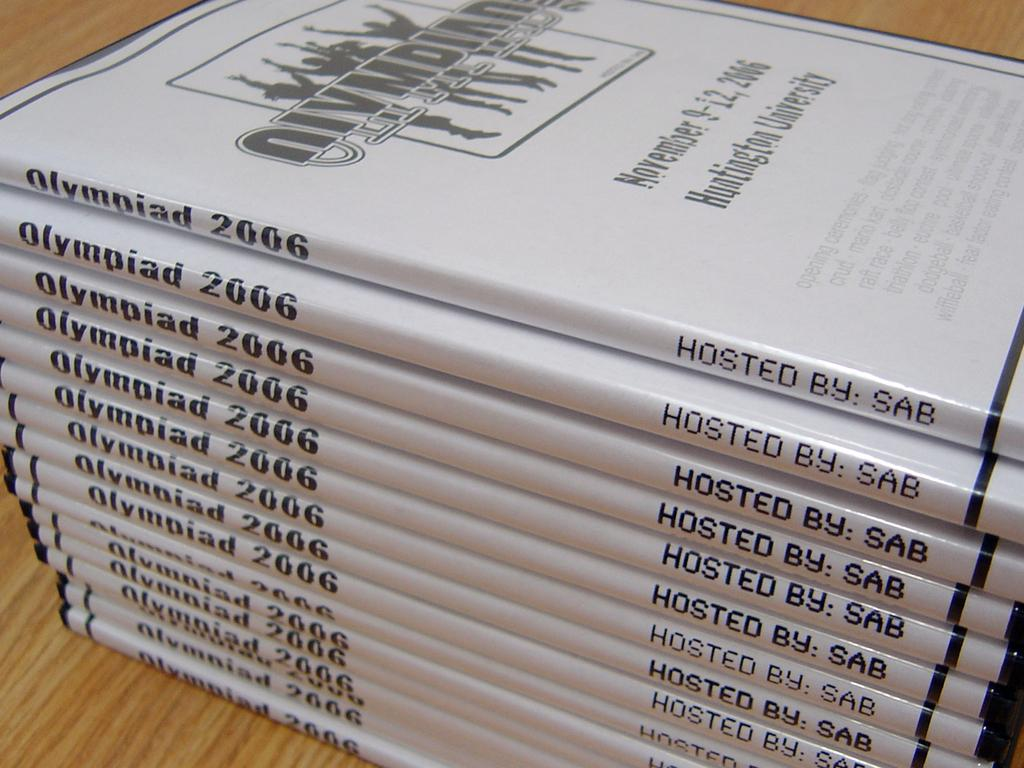<image>
Provide a brief description of the given image. Several white cases that have written Olympiad 2006 written on the side. 